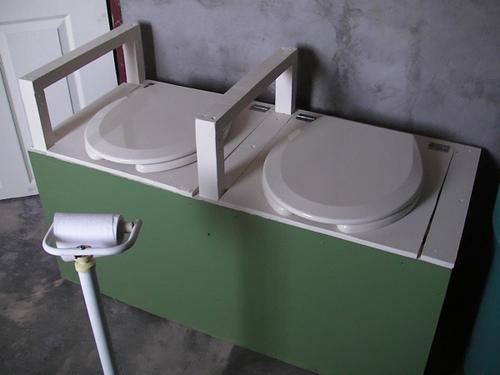How many toilets are pictured?
Keep it brief. 2. How do you expect this toilet to be emptied?
Answer briefly. Manually. Would you be comfortable using this with a buddy?
Be succinct. No. 